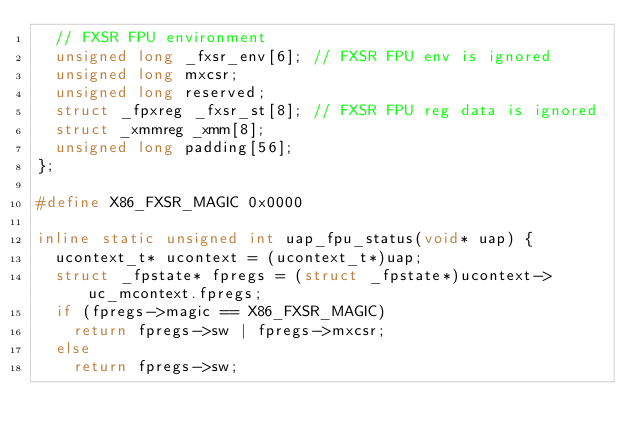Convert code to text. <code><loc_0><loc_0><loc_500><loc_500><_C++_>  // FXSR FPU environment
  unsigned long _fxsr_env[6]; // FXSR FPU env is ignored
  unsigned long mxcsr;
  unsigned long reserved;
  struct _fpxreg _fxsr_st[8]; // FXSR FPU reg data is ignored
  struct _xmmreg _xmm[8];
  unsigned long padding[56];
};

#define X86_FXSR_MAGIC 0x0000

inline static unsigned int uap_fpu_status(void* uap) {
  ucontext_t* ucontext = (ucontext_t*)uap;
  struct _fpstate* fpregs = (struct _fpstate*)ucontext->uc_mcontext.fpregs;
  if (fpregs->magic == X86_FXSR_MAGIC)
    return fpregs->sw | fpregs->mxcsr;
  else
    return fpregs->sw;</code> 